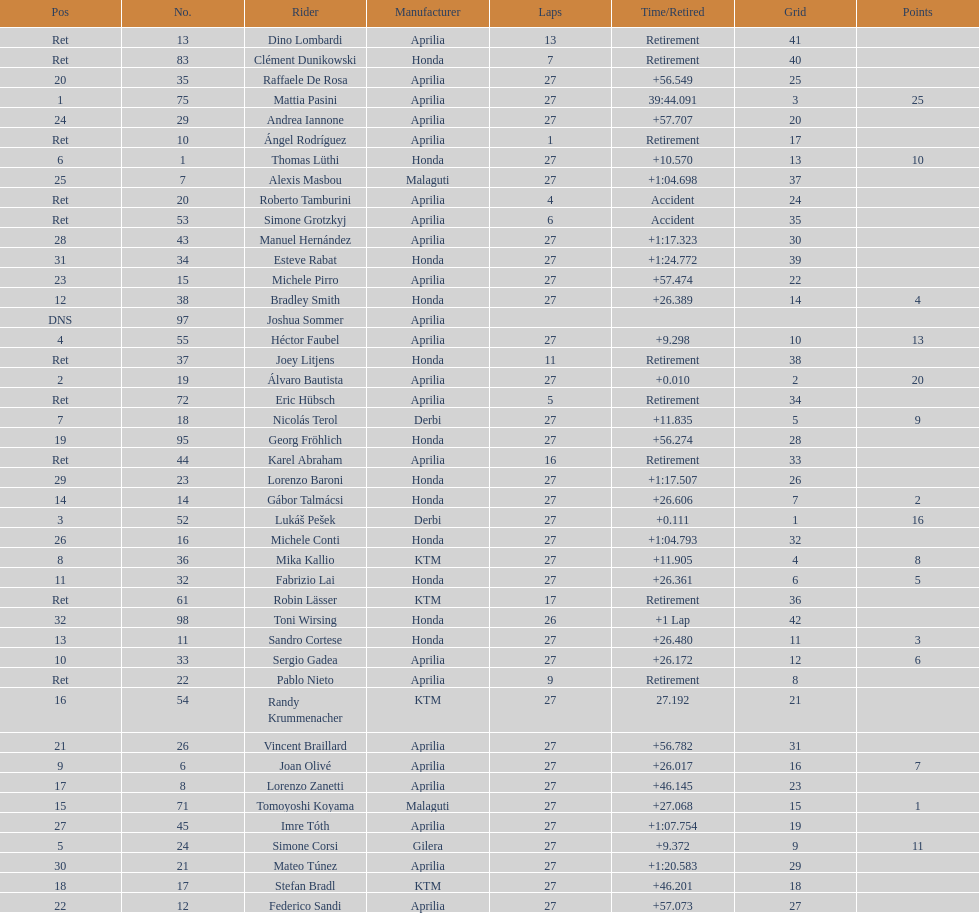Parse the full table. {'header': ['Pos', 'No.', 'Rider', 'Manufacturer', 'Laps', 'Time/Retired', 'Grid', 'Points'], 'rows': [['Ret', '13', 'Dino Lombardi', 'Aprilia', '13', 'Retirement', '41', ''], ['Ret', '83', 'Clément Dunikowski', 'Honda', '7', 'Retirement', '40', ''], ['20', '35', 'Raffaele De Rosa', 'Aprilia', '27', '+56.549', '25', ''], ['1', '75', 'Mattia Pasini', 'Aprilia', '27', '39:44.091', '3', '25'], ['24', '29', 'Andrea Iannone', 'Aprilia', '27', '+57.707', '20', ''], ['Ret', '10', 'Ángel Rodríguez', 'Aprilia', '1', 'Retirement', '17', ''], ['6', '1', 'Thomas Lüthi', 'Honda', '27', '+10.570', '13', '10'], ['25', '7', 'Alexis Masbou', 'Malaguti', '27', '+1:04.698', '37', ''], ['Ret', '20', 'Roberto Tamburini', 'Aprilia', '4', 'Accident', '24', ''], ['Ret', '53', 'Simone Grotzkyj', 'Aprilia', '6', 'Accident', '35', ''], ['28', '43', 'Manuel Hernández', 'Aprilia', '27', '+1:17.323', '30', ''], ['31', '34', 'Esteve Rabat', 'Honda', '27', '+1:24.772', '39', ''], ['23', '15', 'Michele Pirro', 'Aprilia', '27', '+57.474', '22', ''], ['12', '38', 'Bradley Smith', 'Honda', '27', '+26.389', '14', '4'], ['DNS', '97', 'Joshua Sommer', 'Aprilia', '', '', '', ''], ['4', '55', 'Héctor Faubel', 'Aprilia', '27', '+9.298', '10', '13'], ['Ret', '37', 'Joey Litjens', 'Honda', '11', 'Retirement', '38', ''], ['2', '19', 'Álvaro Bautista', 'Aprilia', '27', '+0.010', '2', '20'], ['Ret', '72', 'Eric Hübsch', 'Aprilia', '5', 'Retirement', '34', ''], ['7', '18', 'Nicolás Terol', 'Derbi', '27', '+11.835', '5', '9'], ['19', '95', 'Georg Fröhlich', 'Honda', '27', '+56.274', '28', ''], ['Ret', '44', 'Karel Abraham', 'Aprilia', '16', 'Retirement', '33', ''], ['29', '23', 'Lorenzo Baroni', 'Honda', '27', '+1:17.507', '26', ''], ['14', '14', 'Gábor Talmácsi', 'Honda', '27', '+26.606', '7', '2'], ['3', '52', 'Lukáš Pešek', 'Derbi', '27', '+0.111', '1', '16'], ['26', '16', 'Michele Conti', 'Honda', '27', '+1:04.793', '32', ''], ['8', '36', 'Mika Kallio', 'KTM', '27', '+11.905', '4', '8'], ['11', '32', 'Fabrizio Lai', 'Honda', '27', '+26.361', '6', '5'], ['Ret', '61', 'Robin Lässer', 'KTM', '17', 'Retirement', '36', ''], ['32', '98', 'Toni Wirsing', 'Honda', '26', '+1 Lap', '42', ''], ['13', '11', 'Sandro Cortese', 'Honda', '27', '+26.480', '11', '3'], ['10', '33', 'Sergio Gadea', 'Aprilia', '27', '+26.172', '12', '6'], ['Ret', '22', 'Pablo Nieto', 'Aprilia', '9', 'Retirement', '8', ''], ['16', '54', 'Randy Krummenacher', 'KTM', '27', '27.192', '21', ''], ['21', '26', 'Vincent Braillard', 'Aprilia', '27', '+56.782', '31', ''], ['9', '6', 'Joan Olivé', 'Aprilia', '27', '+26.017', '16', '7'], ['17', '8', 'Lorenzo Zanetti', 'Aprilia', '27', '+46.145', '23', ''], ['15', '71', 'Tomoyoshi Koyama', 'Malaguti', '27', '+27.068', '15', '1'], ['27', '45', 'Imre Tóth', 'Aprilia', '27', '+1:07.754', '19', ''], ['5', '24', 'Simone Corsi', 'Gilera', '27', '+9.372', '9', '11'], ['30', '21', 'Mateo Túnez', 'Aprilia', '27', '+1:20.583', '29', ''], ['18', '17', 'Stefan Bradl', 'KTM', '27', '+46.201', '18', ''], ['22', '12', 'Federico Sandi', 'Aprilia', '27', '+57.073', '27', '']]} Which rider came in first with 25 points? Mattia Pasini. 